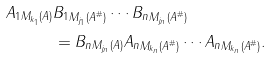<formula> <loc_0><loc_0><loc_500><loc_500>\| A _ { 1 } \| _ { M _ { k _ { 1 } } ( A ) } & \| B _ { 1 } \| _ { M _ { j _ { 1 } } ( A ^ { \# } ) } \cdots \| B _ { n } \| _ { M _ { j _ { n } } ( A ^ { \# } ) } \\ & = \| B _ { n } \| _ { M _ { j _ { n } } ( A ) } \| A _ { n } \| _ { M _ { k _ { n } } ( A ^ { \# } ) } \cdots \| A _ { n } \| _ { M _ { k _ { n } } ( A ^ { \# } ) } .</formula> 